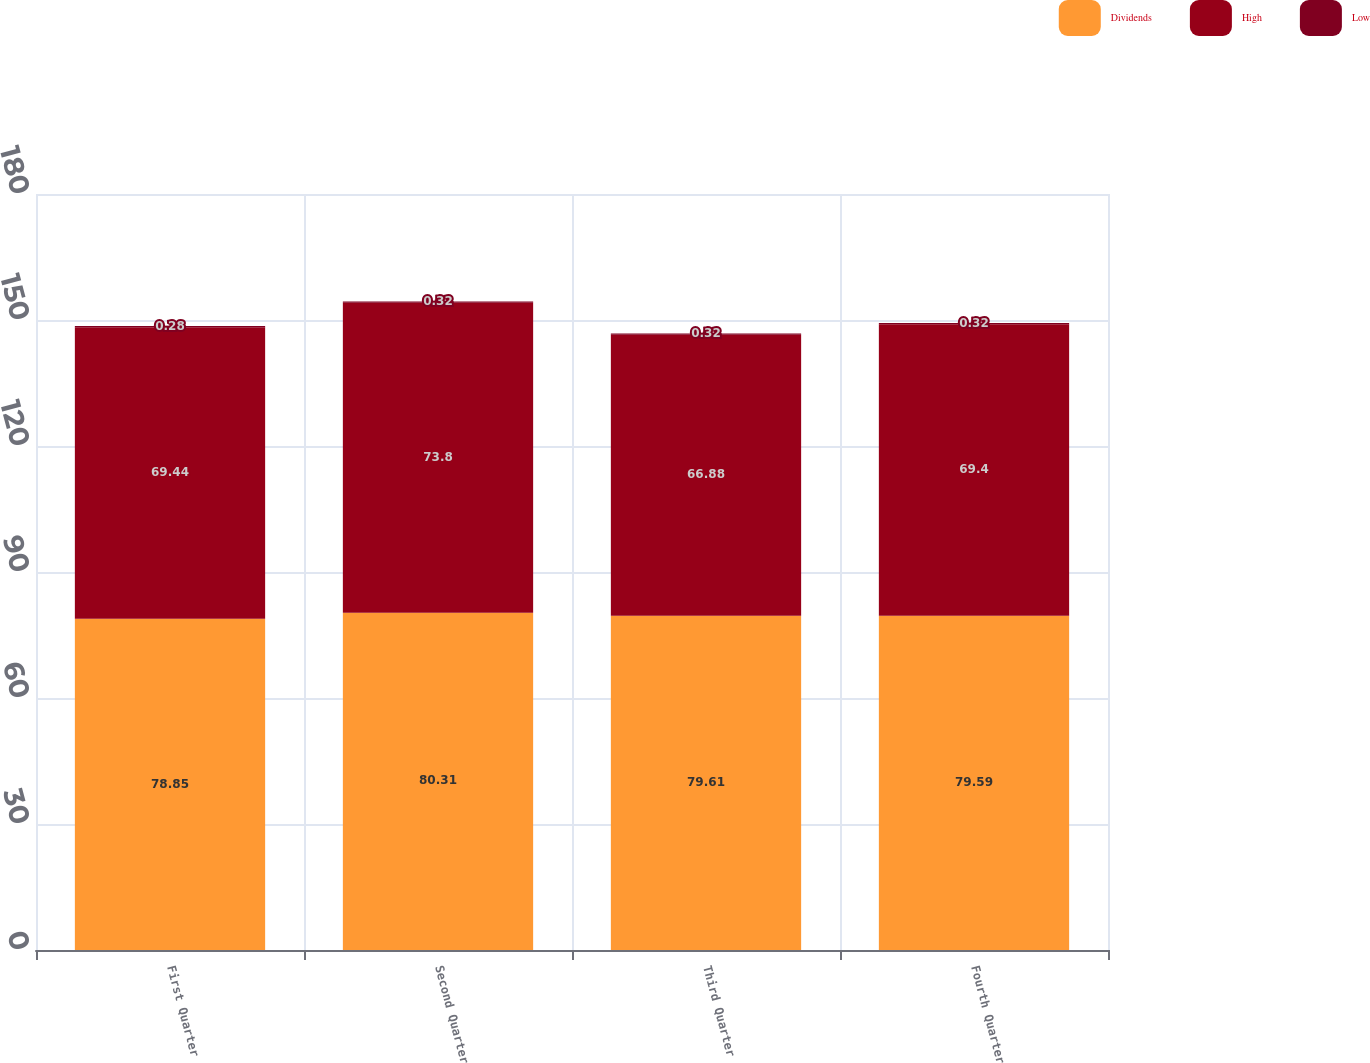<chart> <loc_0><loc_0><loc_500><loc_500><stacked_bar_chart><ecel><fcel>First Quarter<fcel>Second Quarter<fcel>Third Quarter<fcel>Fourth Quarter<nl><fcel>Dividends<fcel>78.85<fcel>80.31<fcel>79.61<fcel>79.59<nl><fcel>High<fcel>69.44<fcel>73.8<fcel>66.88<fcel>69.4<nl><fcel>Low<fcel>0.28<fcel>0.32<fcel>0.32<fcel>0.32<nl></chart> 